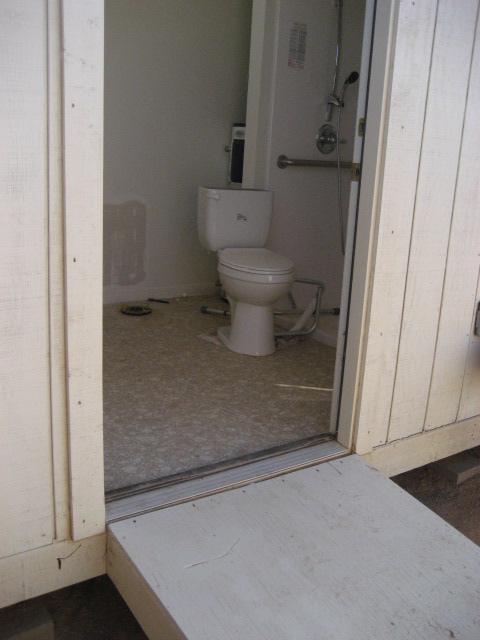Is there a shower in the bathroom?
Give a very brief answer. Yes. Is this a public bathroom?
Quick response, please. No. Is there a door?
Answer briefly. Yes. 